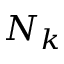<formula> <loc_0><loc_0><loc_500><loc_500>N _ { k }</formula> 